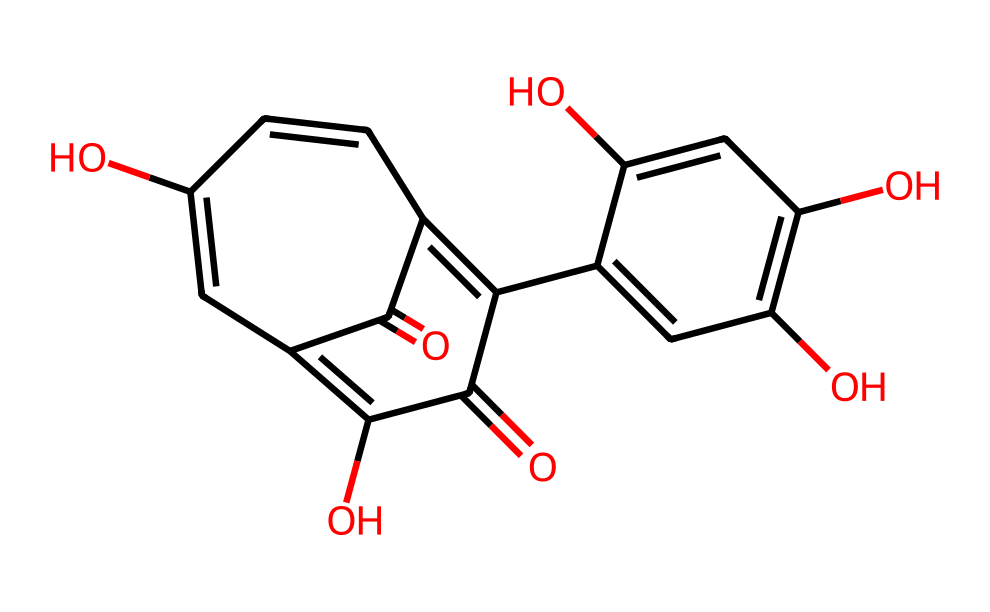how many hydroxyl groups are present in this chemical? The chemical structure has multiple -OH functional groups that can be counted. The visual representation indicates three hydroxyl groups in the benzene rings.
Answer: three what is the molecular weight of this compound? To find the molecular weight, one would typically sum the atomic weights of each atom present in the structure represented by the SMILES. Calculating from the given structure shows a total molecular weight of approximately 286.24 g/mol.
Answer: 286.24 g/mol which characteristic makes this chemical a phenolic antioxidant? The presence of hydroxyl (-OH) groups attached to an aromatic ring gives this compound its phenolic nature and contributes to its antioxidant properties through the ability to donate hydrogen atoms.
Answer: hydroxyl groups what type of bond connects the atoms in the aromatic rings? The aromatic rings in the structure are connected by alternating single and double bonds, which are typical of conjugated systems in phenolic compounds.
Answer: conjugated bonds how many carbon atoms are in this chemical? By analyzing the structure from the SMILES representation, there are a total of 15 carbon atoms in the compound.
Answer: fifteen is this compound water-soluble? Phenolic compounds typically have varied solubility; however, due to multiple hydroxyl groups present which can form hydrogen bonds with water, this chemical is likely to be moderately water-soluble.
Answer: moderately soluble what role do the carboxyl groups play in this chemical? The carboxyl groups present in the structure can participate in hydrogen bonding and can also enhance the solubility, while contributing to the overall antioxidant activity of the compound.
Answer: enhance solubility 